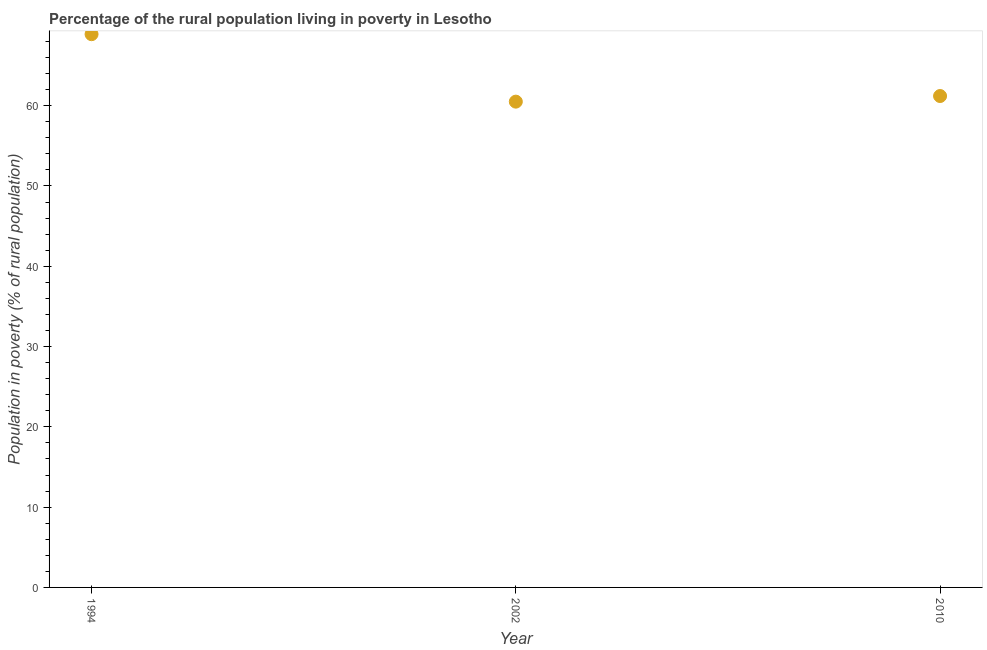What is the percentage of rural population living below poverty line in 2002?
Offer a very short reply. 60.5. Across all years, what is the maximum percentage of rural population living below poverty line?
Your answer should be very brief. 68.9. Across all years, what is the minimum percentage of rural population living below poverty line?
Give a very brief answer. 60.5. In which year was the percentage of rural population living below poverty line minimum?
Offer a terse response. 2002. What is the sum of the percentage of rural population living below poverty line?
Provide a short and direct response. 190.6. What is the difference between the percentage of rural population living below poverty line in 1994 and 2010?
Offer a terse response. 7.7. What is the average percentage of rural population living below poverty line per year?
Provide a succinct answer. 63.53. What is the median percentage of rural population living below poverty line?
Offer a terse response. 61.2. Do a majority of the years between 2002 and 2010 (inclusive) have percentage of rural population living below poverty line greater than 22 %?
Offer a very short reply. Yes. What is the ratio of the percentage of rural population living below poverty line in 1994 to that in 2010?
Your answer should be very brief. 1.13. Is the percentage of rural population living below poverty line in 1994 less than that in 2010?
Provide a succinct answer. No. Is the difference between the percentage of rural population living below poverty line in 2002 and 2010 greater than the difference between any two years?
Give a very brief answer. No. What is the difference between the highest and the second highest percentage of rural population living below poverty line?
Offer a very short reply. 7.7. What is the difference between the highest and the lowest percentage of rural population living below poverty line?
Offer a terse response. 8.4. Does the percentage of rural population living below poverty line monotonically increase over the years?
Give a very brief answer. No. Are the values on the major ticks of Y-axis written in scientific E-notation?
Offer a very short reply. No. Does the graph contain grids?
Your response must be concise. No. What is the title of the graph?
Ensure brevity in your answer.  Percentage of the rural population living in poverty in Lesotho. What is the label or title of the X-axis?
Make the answer very short. Year. What is the label or title of the Y-axis?
Provide a short and direct response. Population in poverty (% of rural population). What is the Population in poverty (% of rural population) in 1994?
Your answer should be very brief. 68.9. What is the Population in poverty (% of rural population) in 2002?
Give a very brief answer. 60.5. What is the Population in poverty (% of rural population) in 2010?
Keep it short and to the point. 61.2. What is the difference between the Population in poverty (% of rural population) in 1994 and 2002?
Make the answer very short. 8.4. What is the difference between the Population in poverty (% of rural population) in 1994 and 2010?
Make the answer very short. 7.7. What is the ratio of the Population in poverty (% of rural population) in 1994 to that in 2002?
Keep it short and to the point. 1.14. What is the ratio of the Population in poverty (% of rural population) in 1994 to that in 2010?
Provide a succinct answer. 1.13. 